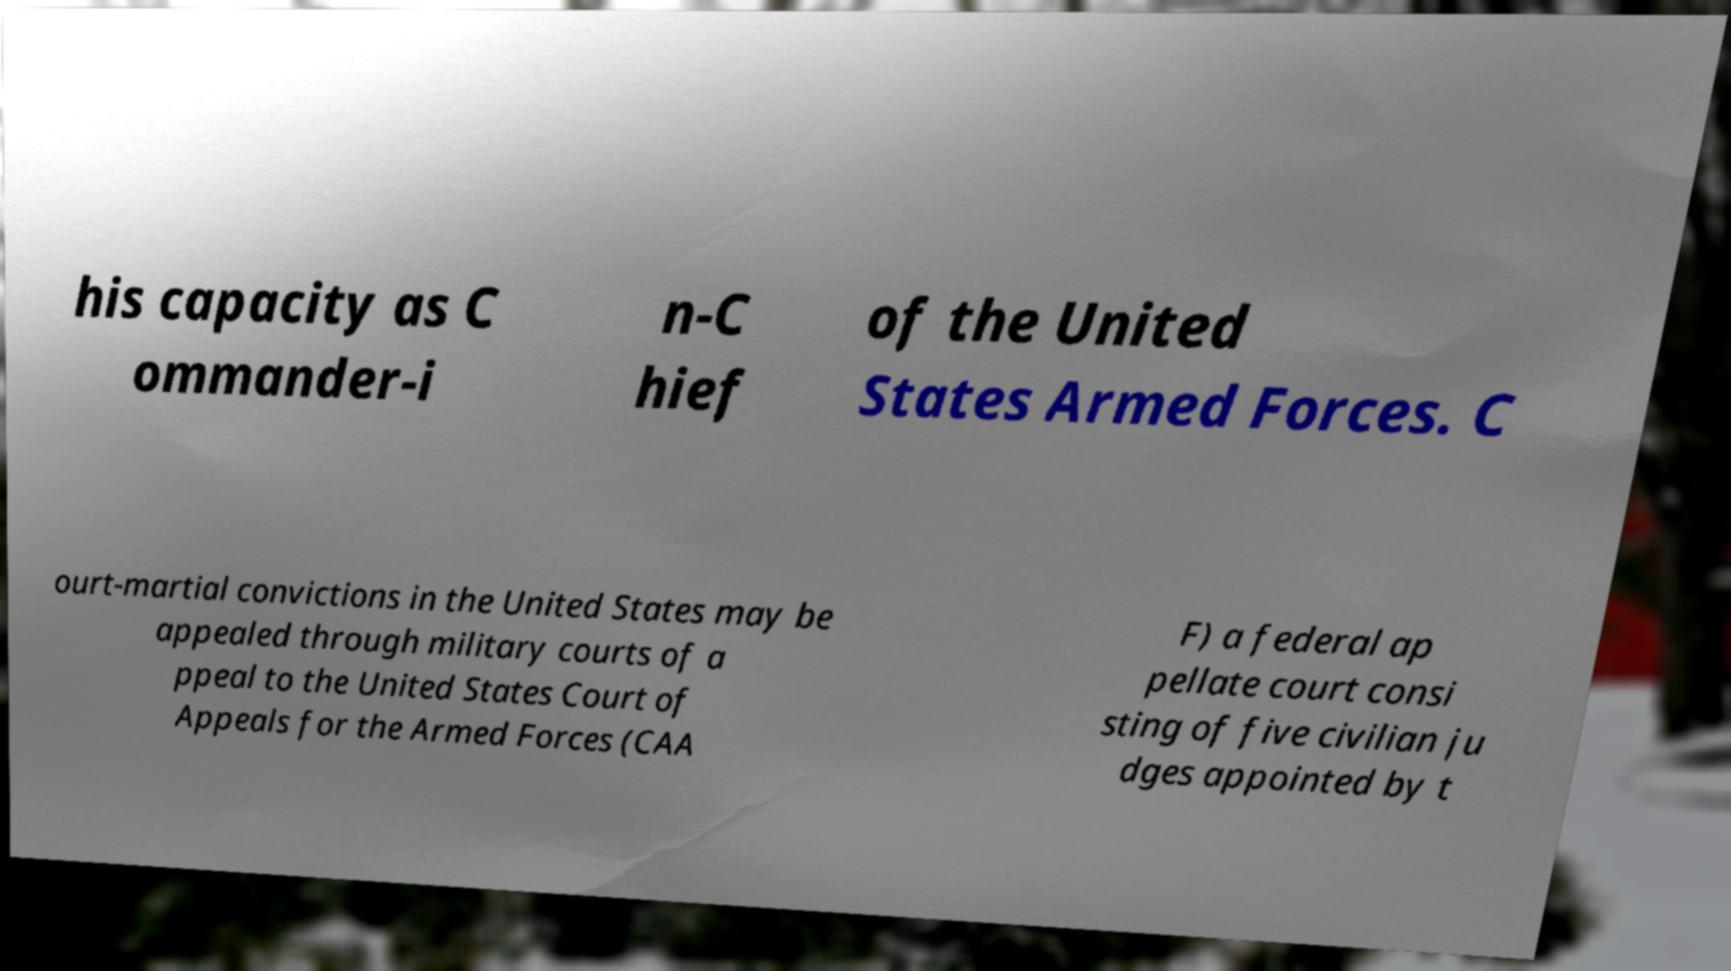Could you assist in decoding the text presented in this image and type it out clearly? his capacity as C ommander-i n-C hief of the United States Armed Forces. C ourt-martial convictions in the United States may be appealed through military courts of a ppeal to the United States Court of Appeals for the Armed Forces (CAA F) a federal ap pellate court consi sting of five civilian ju dges appointed by t 